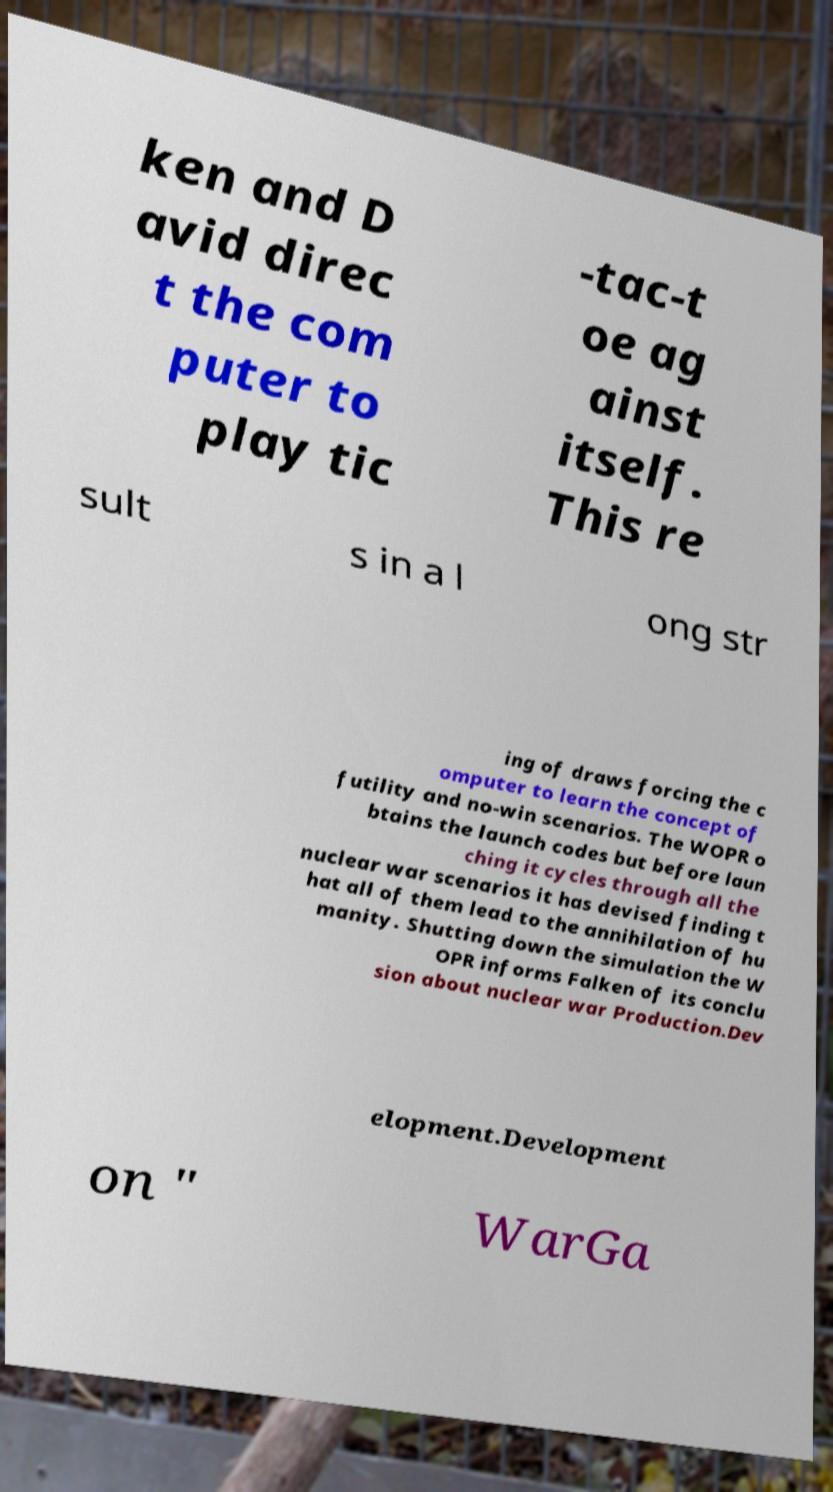Please read and relay the text visible in this image. What does it say? ken and D avid direc t the com puter to play tic -tac-t oe ag ainst itself. This re sult s in a l ong str ing of draws forcing the c omputer to learn the concept of futility and no-win scenarios. The WOPR o btains the launch codes but before laun ching it cycles through all the nuclear war scenarios it has devised finding t hat all of them lead to the annihilation of hu manity. Shutting down the simulation the W OPR informs Falken of its conclu sion about nuclear war Production.Dev elopment.Development on " WarGa 